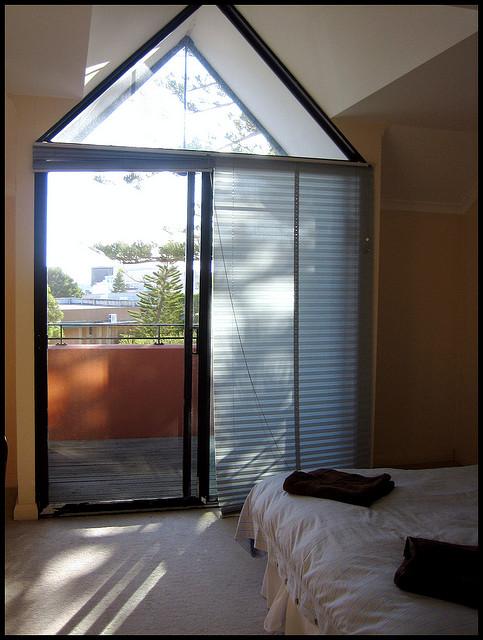How many trees are on the left side?
Write a very short answer. 2. Is the sun shining in the room?
Give a very brief answer. Yes. Is this a glass door or a glass window?
Give a very brief answer. Door. Would this bed be comfortable?
Quick response, please. Yes. Where was the picture taken of the bed?
Give a very brief answer. Bedroom. Is that towel on the chair?
Quick response, please. No. Is the bed made?
Short answer required. Yes. Does the bed have sheets on it?
Short answer required. Yes. Is this a bedroom?
Be succinct. Yes. Is there a table in this picture?
Keep it brief. No. Why are the blinds closed?
Quick response, please. Yes. What is sitting on the bed?
Be succinct. Towels. What shape is the door and window of?
Concise answer only. House. Are the curtains opaque?
Give a very brief answer. No. 